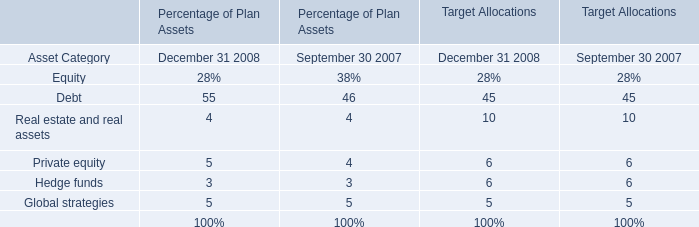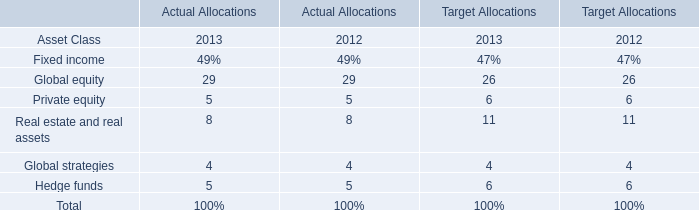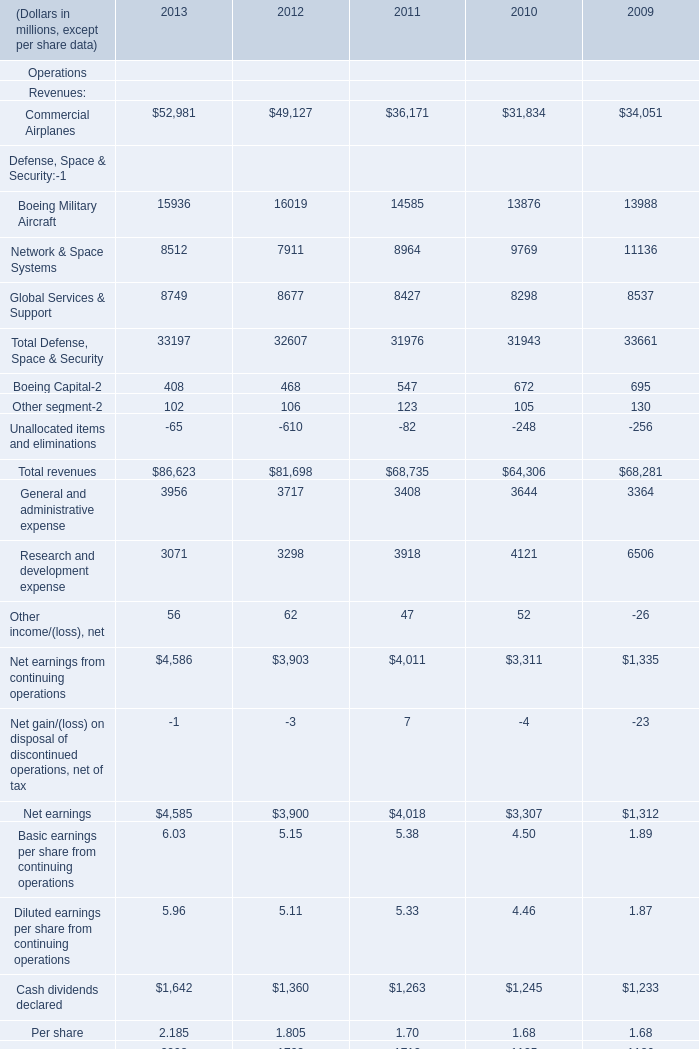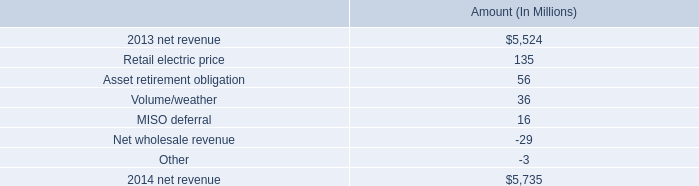what is the percent change in net revenue from 2013 to 2014? 
Computations: ((5735 - 5524) / 5524)
Answer: 0.0382. 